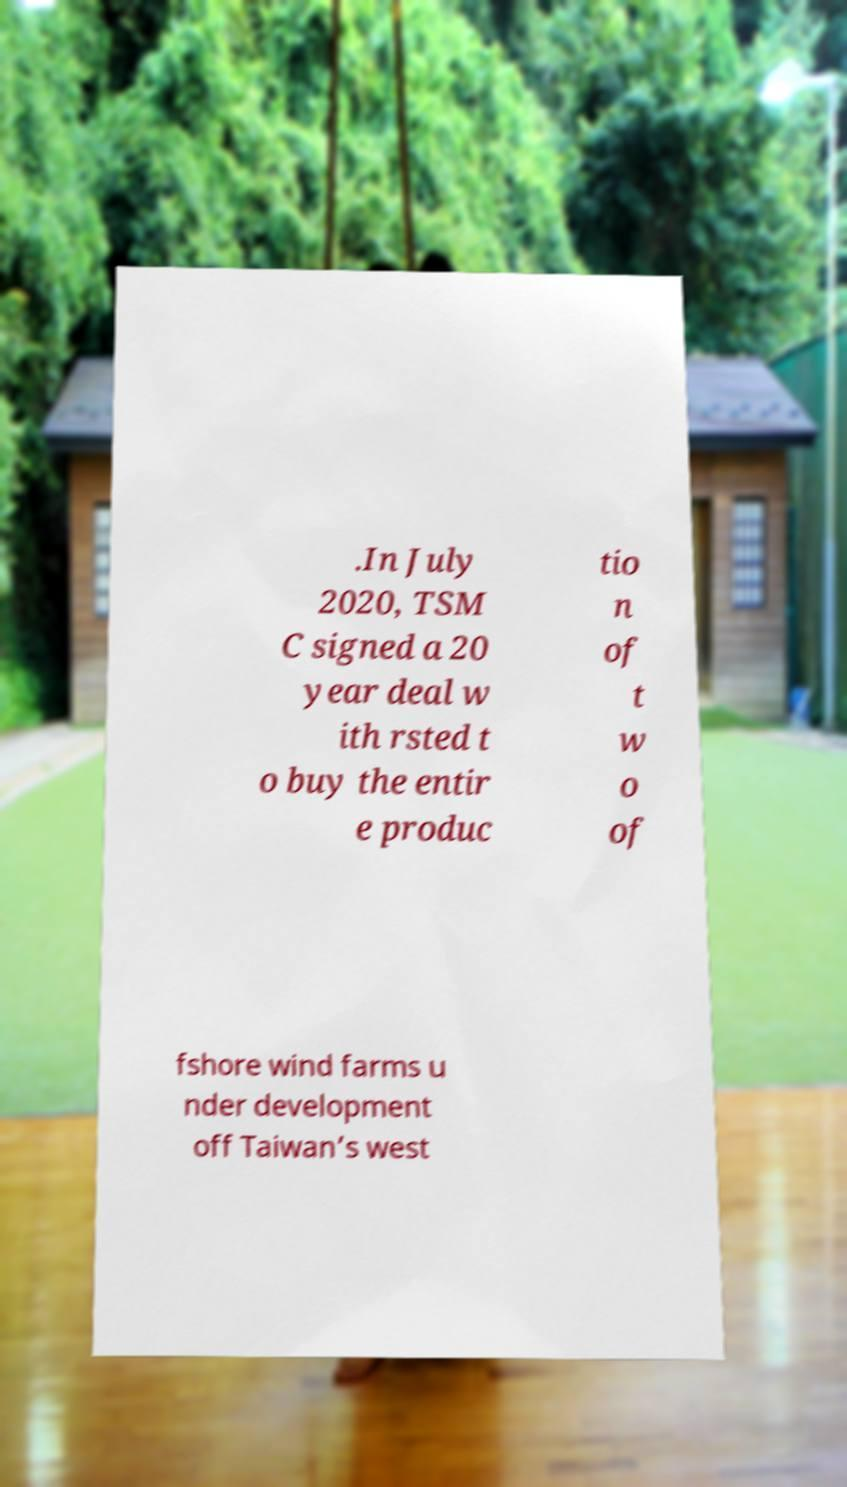Please read and relay the text visible in this image. What does it say? .In July 2020, TSM C signed a 20 year deal w ith rsted t o buy the entir e produc tio n of t w o of fshore wind farms u nder development off Taiwan’s west 